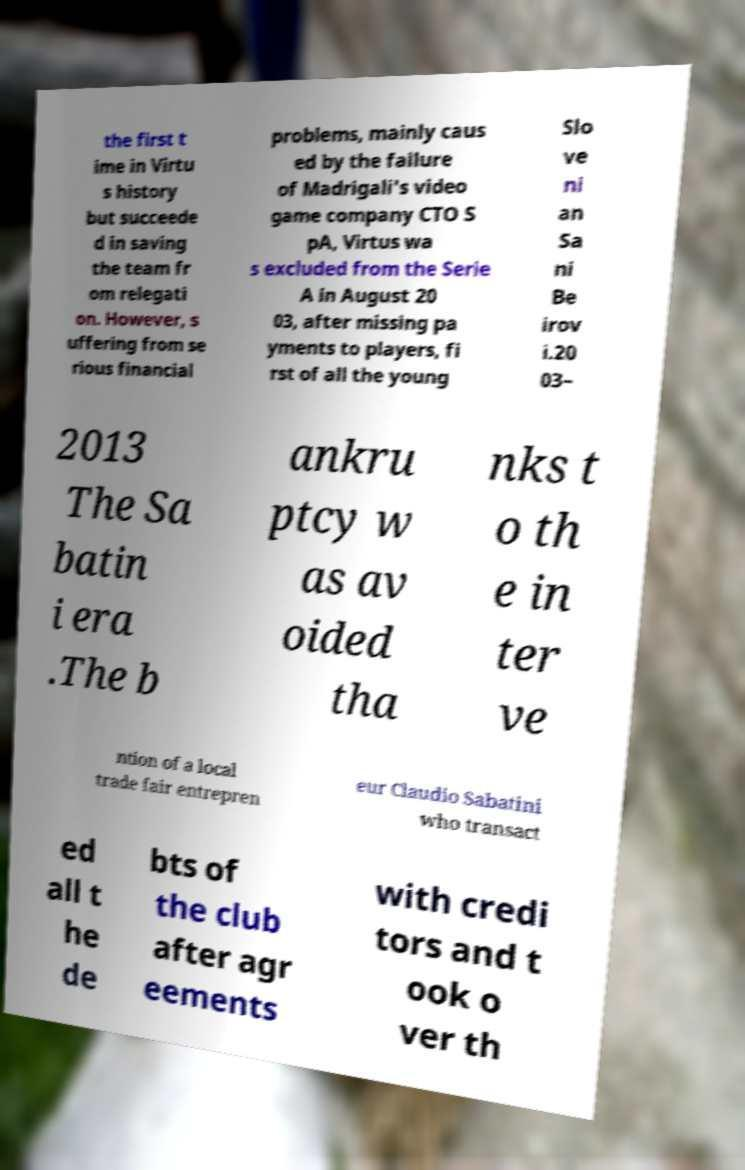Please identify and transcribe the text found in this image. the first t ime in Virtu s history but succeede d in saving the team fr om relegati on. However, s uffering from se rious financial problems, mainly caus ed by the failure of Madrigali's video game company CTO S pA, Virtus wa s excluded from the Serie A in August 20 03, after missing pa yments to players, fi rst of all the young Slo ve ni an Sa ni Be irov i.20 03– 2013 The Sa batin i era .The b ankru ptcy w as av oided tha nks t o th e in ter ve ntion of a local trade fair entrepren eur Claudio Sabatini who transact ed all t he de bts of the club after agr eements with credi tors and t ook o ver th 